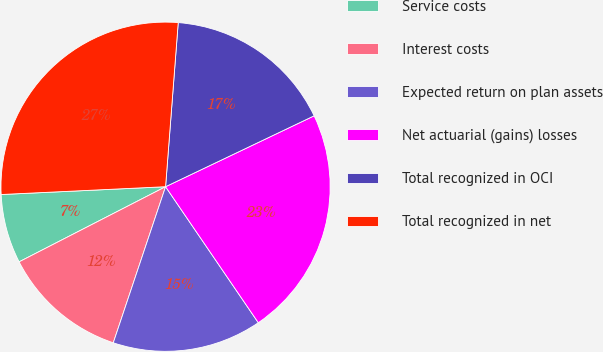Convert chart to OTSL. <chart><loc_0><loc_0><loc_500><loc_500><pie_chart><fcel>Service costs<fcel>Interest costs<fcel>Expected return on plan assets<fcel>Net actuarial (gains) losses<fcel>Total recognized in OCI<fcel>Total recognized in net<nl><fcel>6.79%<fcel>12.31%<fcel>14.67%<fcel>22.56%<fcel>16.69%<fcel>26.98%<nl></chart> 